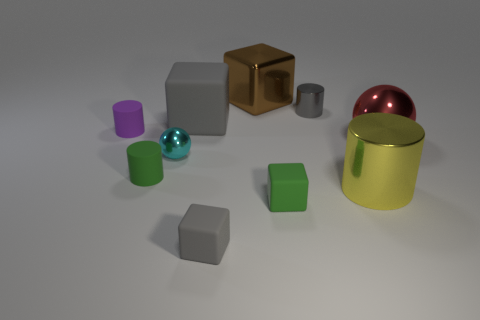There is a purple matte thing that is the same shape as the gray metal object; what is its size?
Provide a short and direct response. Small. Does the tiny metal sphere have the same color as the big matte block?
Provide a short and direct response. No. How many balls are in front of the shiny sphere that is to the right of the large shiny thing in front of the red ball?
Provide a short and direct response. 1. Are there more rubber blocks than big objects?
Your response must be concise. No. What number of large blue objects are there?
Provide a succinct answer. 0. There is a gray object to the right of the object that is behind the small gray object that is behind the large metallic ball; what shape is it?
Make the answer very short. Cylinder. Is the number of big shiny cubes in front of the tiny purple object less than the number of cylinders on the left side of the yellow object?
Provide a short and direct response. Yes. There is a green object right of the tiny cyan ball; is it the same shape as the large object that is left of the brown cube?
Ensure brevity in your answer.  Yes. The tiny rubber object that is in front of the green object on the right side of the small sphere is what shape?
Keep it short and to the point. Cube. The cube that is the same color as the big matte object is what size?
Provide a short and direct response. Small. 